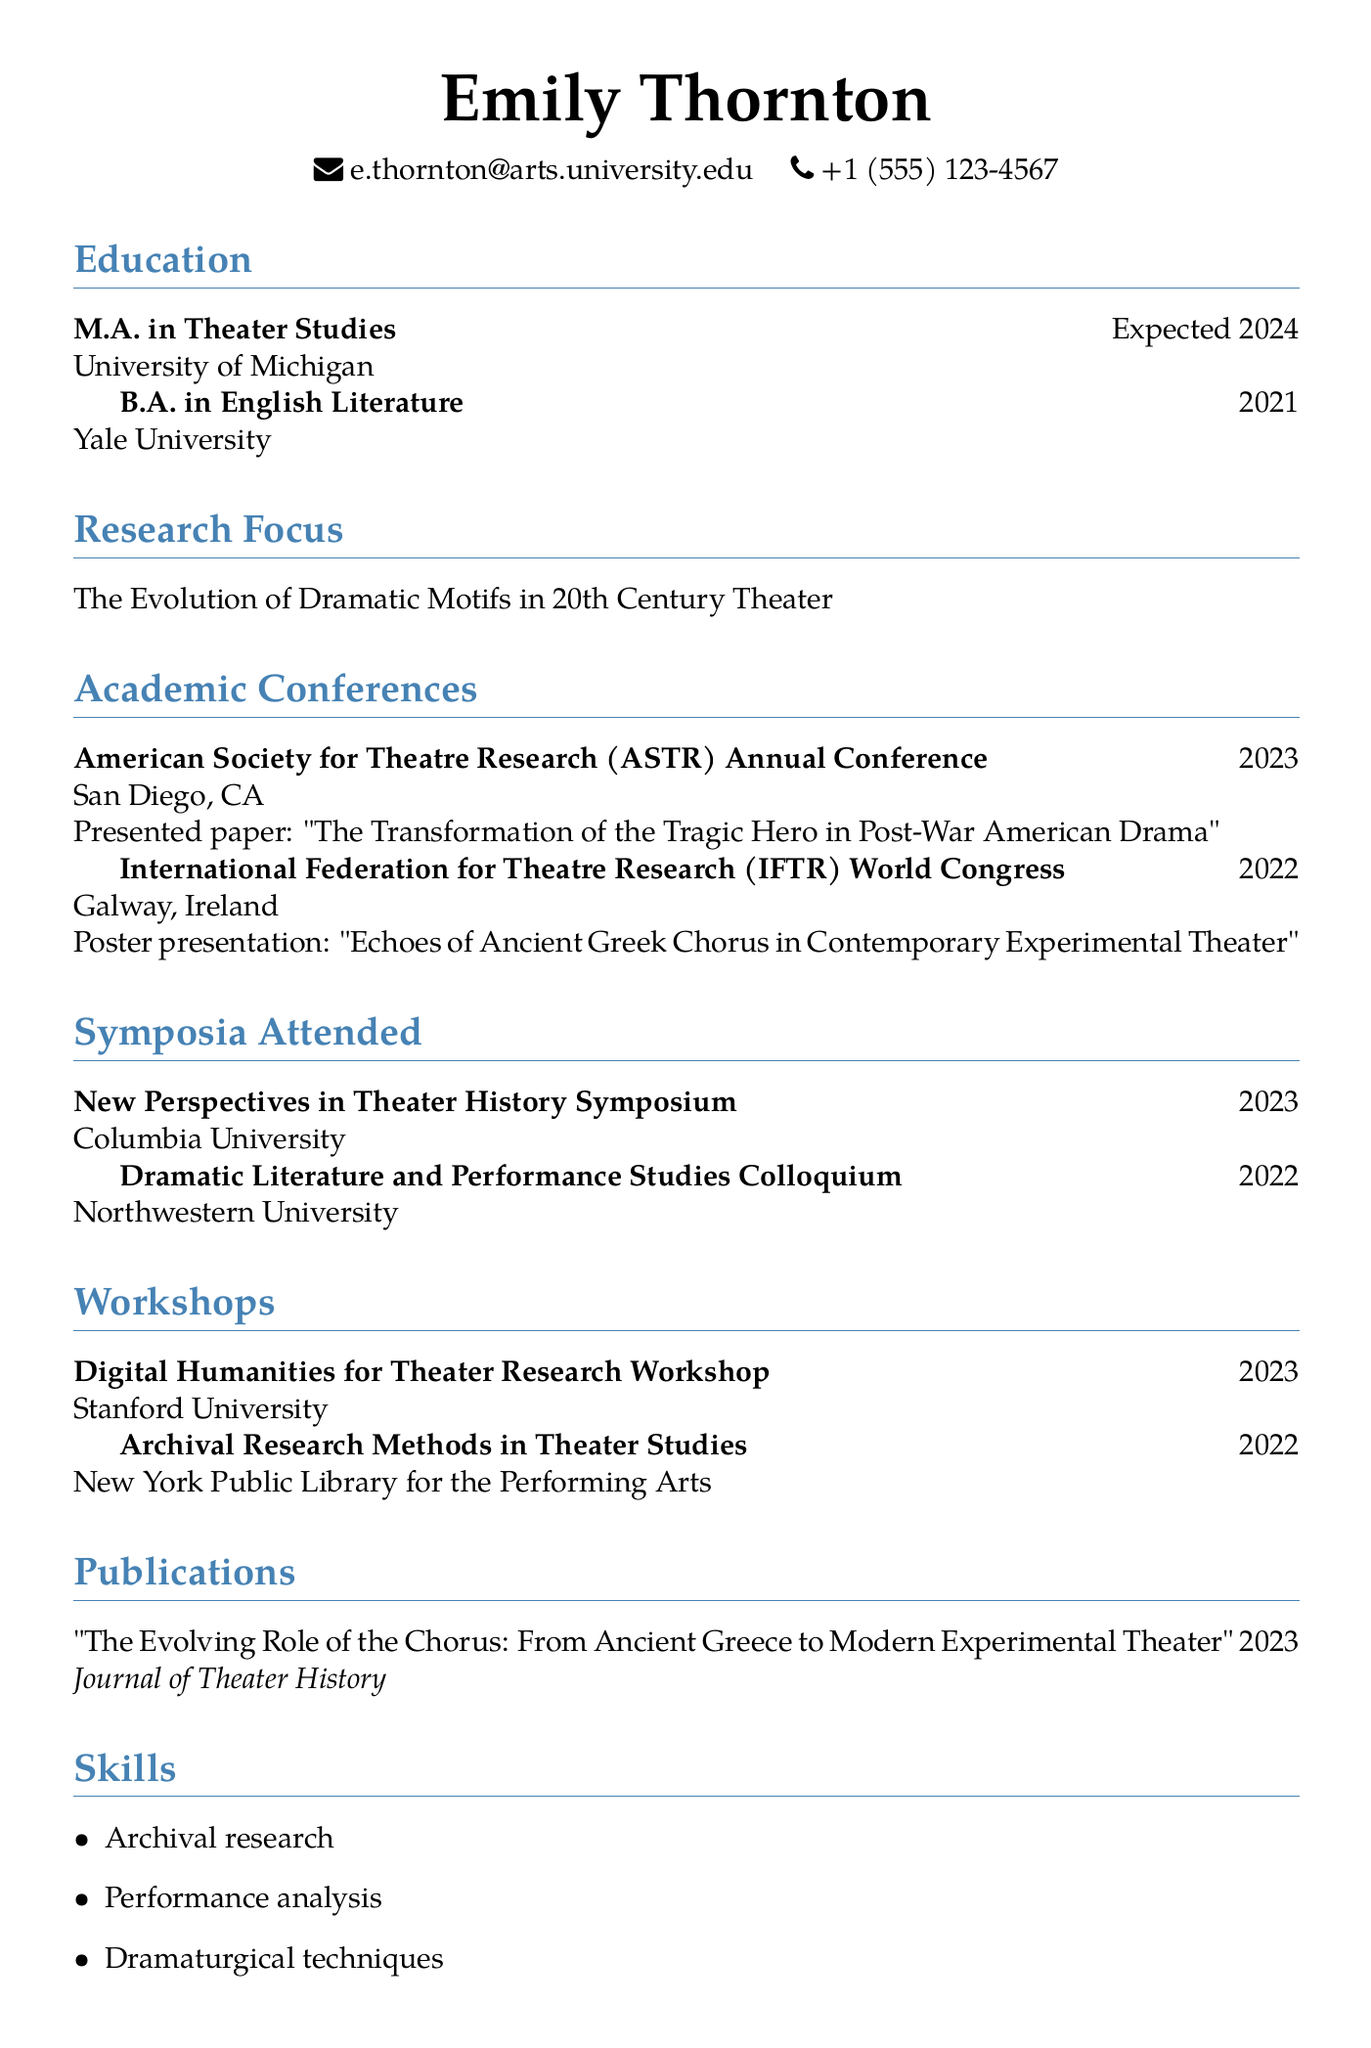what is Emily Thornton's email address? The email address is listed in the personal information section of the document.
Answer: e.thornton@arts.university.edu which university is Emily Thornton expected to graduate from? The university for her M.A. in Theater Studies is stated in the education section.
Answer: University of Michigan what was the title of the paper presented at the ASTR Annual Conference? The title of the paper is mentioned in the academic conferences section under ASTR Annual Conference.
Answer: The Transformation of the Tragic Hero in Post-War American Drama in what year did Emily attend the International Federation for Theatre Research World Congress? The year is specified in the academic conferences section for the IFTR World Congress.
Answer: 2022 how many workshops has Emily Thornton attended according to the document? The number of workshops is found by counting entries in the workshops section.
Answer: 2 what is the primary research focus stated in the CV? The research focus is outlined in a dedicated section of the document.
Answer: The Evolution of Dramatic Motifs in 20th Century Theater which skill related to digital humanities is listed in Emily Thornton's CV? Digital humanities tools for theater research is mentioned in the skills section of the document.
Answer: Digital humanities tools for theater research where was the New Perspectives in Theater History Symposium held? The location of the symposium is provided in the symposia attended section.
Answer: Columbia University what type of presentation did Emily make at the IFTR World Congress? The type of presentation is mentioned in the academic conferences section.
Answer: Poster presentation 